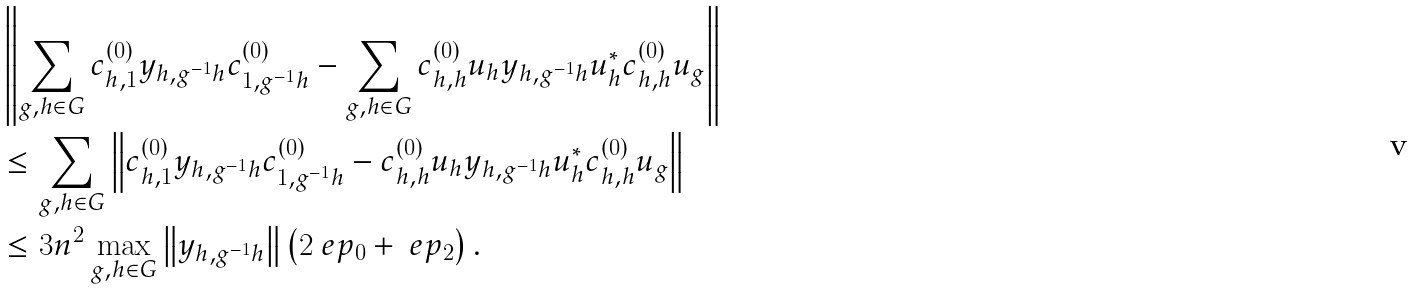Convert formula to latex. <formula><loc_0><loc_0><loc_500><loc_500>& \left \| \sum _ { g , h \in G } c _ { h , 1 } ^ { ( 0 ) } y _ { h , g ^ { - 1 } h } c _ { 1 , g ^ { - 1 } h } ^ { ( 0 ) } - \sum _ { g , h \in G } c _ { h , h } ^ { ( 0 ) } u _ { h } y _ { h , g ^ { - 1 } h } u _ { h } ^ { * } c _ { h , h } ^ { ( 0 ) } u _ { g } \right \| \\ & \leq \sum _ { g , h \in G } \left \| c _ { h , 1 } ^ { ( 0 ) } y _ { h , g ^ { - 1 } h } c _ { 1 , g ^ { - 1 } h } ^ { ( 0 ) } - c _ { h , h } ^ { ( 0 ) } u _ { h } y _ { h , g ^ { - 1 } h } u _ { h } ^ { * } c _ { h , h } ^ { ( 0 ) } u _ { g } \right \| \\ & \leq 3 n ^ { 2 } \max _ { g , h \in G } \left \| y _ { h , g ^ { - 1 } h } \right \| \left ( 2 \ e p _ { 0 } + \ e p _ { 2 } \right ) .</formula> 